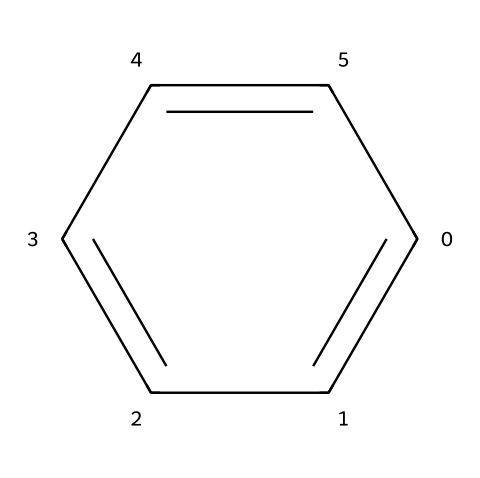What is the name of this chemical compound? The SMILES representation corresponds to the chemical structure of benzene, which is a well-known aromatic compound with the formula C6H6.
Answer: benzene How many carbon atoms are present in this compound? In the SMILES representation, "c" indicates carbon atoms, and counting the six "c" elements shows that there are six carbon atoms in total.
Answer: 6 What type of bonding is primarily present in this compound? The structure of benzene features alternating double bonds, which indicate that it has conjugated π-bonding; thus, it predominantly exhibits π-type bonding.
Answer: π-bonding How many hydrogen atoms are attached to this benzene ring? The benzene structure has six carbon atoms and, following its formula C6H6, each carbon is bonded to a single hydrogen atom; therefore, there are six hydrogen atoms attached.
Answer: 6 What functional group is absent in this compound? The structure and formula of benzene reveal that it does not contain functional groups like hydroxyl (-OH) or carboxyl (-COOH), making it purely an aromatic hydrocarbon without these functional groups.
Answer: hydroxyl, carboxyl Which property makes benzene classified as a carcinogen? The resonance stability of benzene, along with its electron-rich nature, leads to its ability to form reactive intermediates that can interact with cellular macromolecules, which contributes to its carcinogenic properties.
Answer: resonance stability 